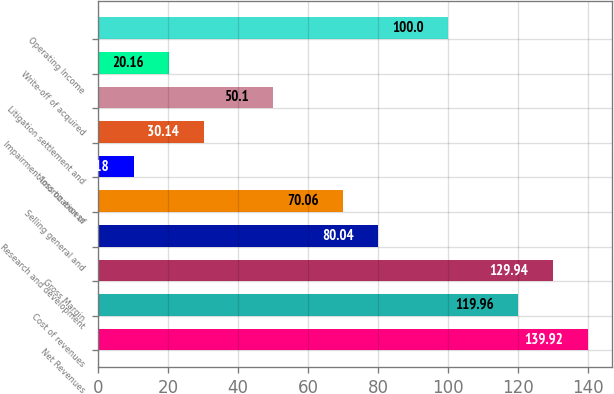Convert chart. <chart><loc_0><loc_0><loc_500><loc_500><bar_chart><fcel>Net Revenues<fcel>Cost of revenues<fcel>Gross Margin<fcel>Research and development<fcel>Selling general and<fcel>Amortization of<fcel>Impairment loss on excess<fcel>Litigation settlement and<fcel>Write-off of acquired<fcel>Operating Income<nl><fcel>139.92<fcel>119.96<fcel>129.94<fcel>80.04<fcel>70.06<fcel>10.18<fcel>30.14<fcel>50.1<fcel>20.16<fcel>100<nl></chart> 